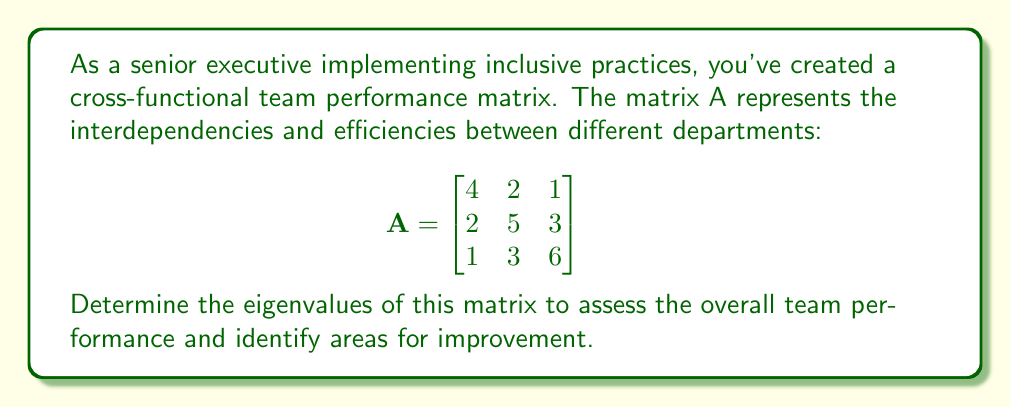What is the answer to this math problem? To find the eigenvalues of matrix A, we need to solve the characteristic equation:

1) First, we set up the equation: $det(A - \lambda I) = 0$, where $\lambda$ represents the eigenvalues and I is the 3x3 identity matrix.

2) Expand the determinant:
   $$det\begin{bmatrix}
   4-\lambda & 2 & 1 \\
   2 & 5-\lambda & 3 \\
   1 & 3 & 6-\lambda
   \end{bmatrix} = 0$$

3) Calculate the determinant:
   $(4-\lambda)[(5-\lambda)(6-\lambda)-9] - 2[2(6-\lambda)-3] + 1[2\cdot3-(5-\lambda)] = 0$

4) Simplify:
   $(4-\lambda)[(30-11\lambda+\lambda^2)-9] - 2[12-2\lambda-3] + [6-(5-\lambda)] = 0$
   $(4-\lambda)(21-11\lambda+\lambda^2) - 2(9-2\lambda) + (1+\lambda) = 0$

5) Expand:
   $84-44\lambda+4\lambda^2-21\lambda+11\lambda^2-\lambda^3 - 18+4\lambda + 1+\lambda = 0$

6) Combine like terms:
   $-\lambda^3+15\lambda^2-60\lambda+67 = 0$

7) This is the characteristic polynomial. To find the roots (eigenvalues), we can use the cubic formula or numerical methods. The roots are:

   $\lambda_1 \approx 2$
   $\lambda_2 \approx 5$
   $\lambda_3 \approx 8$

These eigenvalues represent the principal axes of performance in your cross-functional team. The largest eigenvalue (8) indicates the direction of highest performance, while the smallest (2) might indicate areas needing improvement.
Answer: $\lambda_1 = 2$, $\lambda_2 = 5$, $\lambda_3 = 8$ 